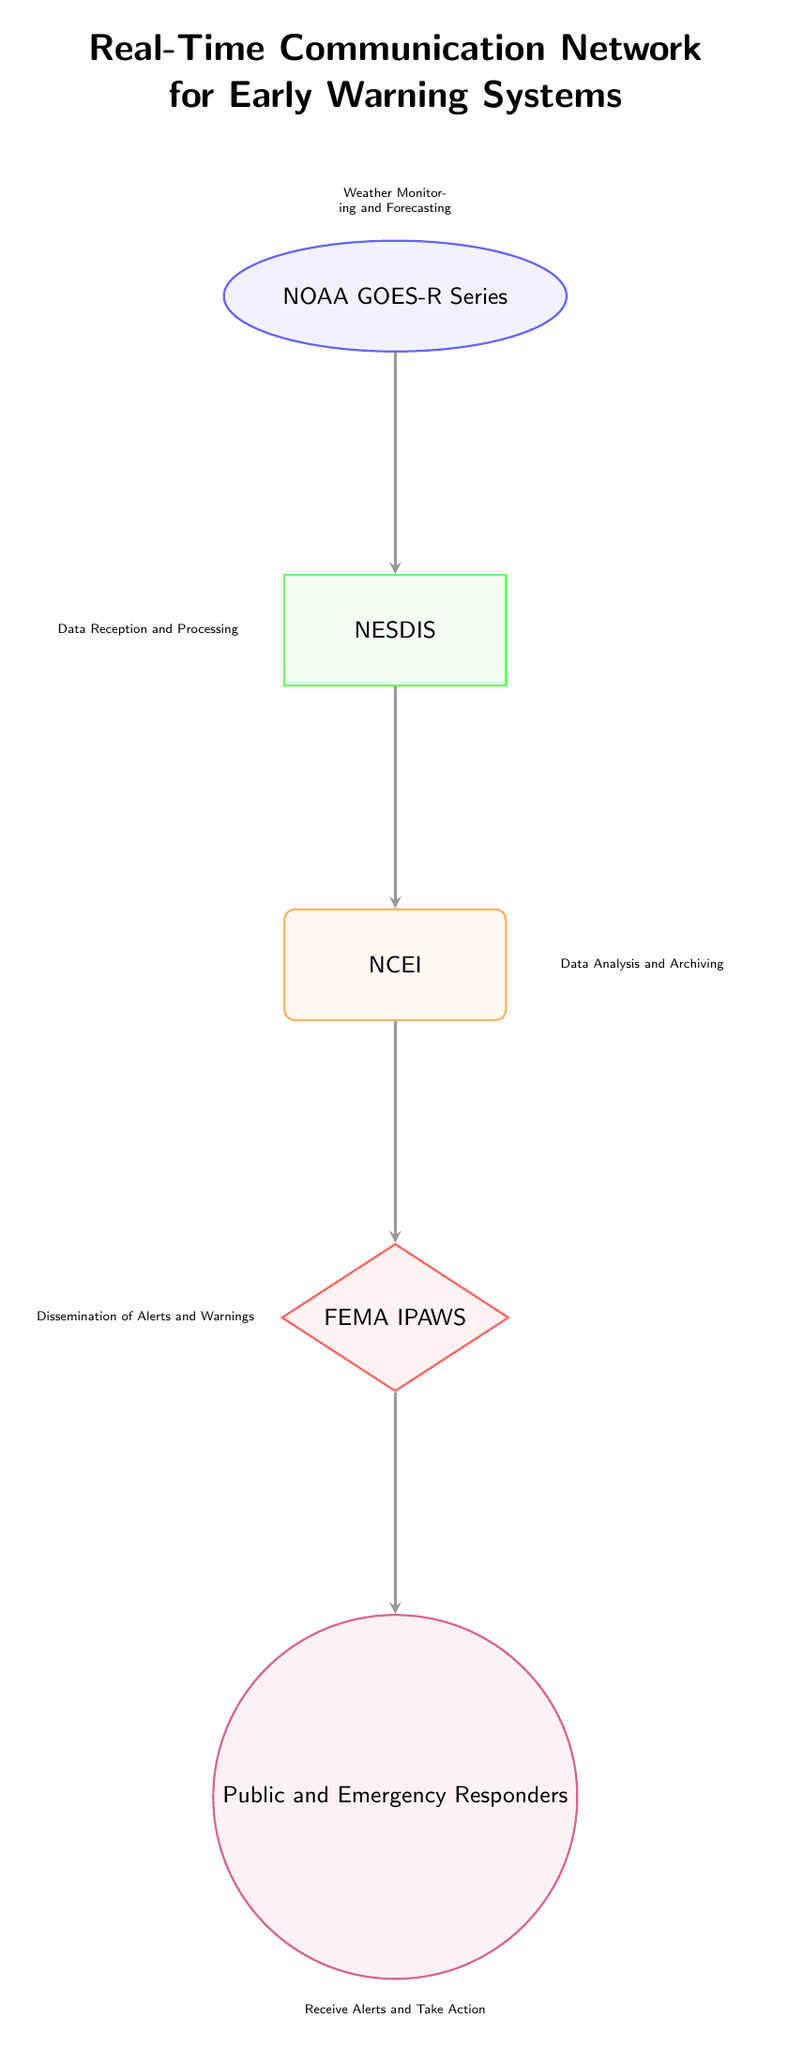What is the first node in the diagram? The diagram starts with the "NOAA GOES-R Series" node, which is positioned at the top and represents the satellite involved in weather monitoring and forecasting.
Answer: NOAA GOES-R Series How many nodes are present in total? Counting the nodes, there are five distinct elements: NOAA GOES-R Series, NESDIS, NCEI, FEMA IPAWS, and the Public and Emergency Responders.
Answer: 5 What is the function of the Ground Station node? The function listed for the Ground Station node, which is "NESDIS," is to provide data reception and processing. This is directly stated in the corresponding label on the diagram.
Answer: Data Reception and Processing Which nodes are directly linked to the Data Processing Center? The Data Processing Center, labeled "NCEI," has a direct link to only one node below it, which is the Early Warning System labeled as "FEMA IPAWS."
Answer: FEMA IPAWS What is the last step before reaching the end users? The last step in the flow of information before reaching the end users is the dissemination of alerts and warnings performed by FEMA IPAWS. This action is indicated in the diagram's labeling.
Answer: Dissemination of Alerts and Warnings How many functions are associated with the End Users? The function associated with the End Users, identified as Public and Emergency Responders, is to receive alerts and take action, which counts as one main function.
Answer: Receive Alerts and Take Action From which node does the Early Warning System receive input? The Early Warning System receives input from the Data Processing Center, "NCEI," which processes the satellite data and sends it to the next stage of the network.
Answer: Data Processing Center What role does the NOAA GOES-R Series play in this network? The NOAA GOES-R Series serves as the starting point for the network by monitoring and forecasting weather conditions, providing crucial information to the entire system.
Answer: Weather Monitoring and Forecasting What type of diagram is represented here? The diagram clearly represents a network diagram, showcasing the flow of information between various components essential for early warning systems utilizing satellite data.
Answer: Network Diagram 